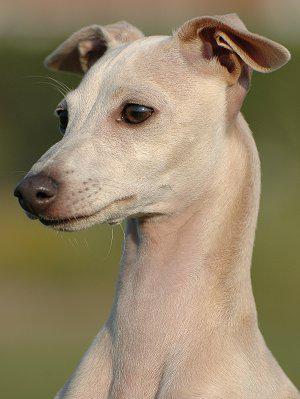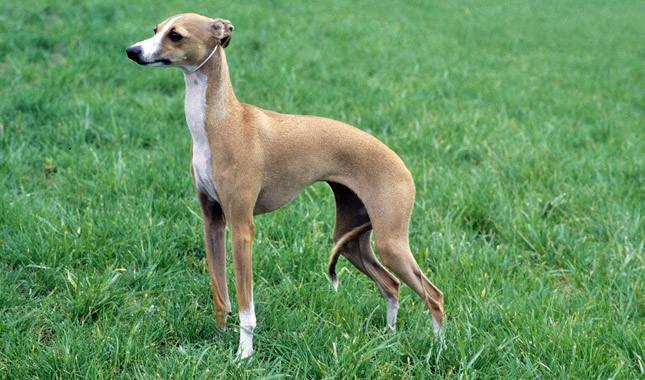The first image is the image on the left, the second image is the image on the right. For the images shown, is this caption "there is a gray dog standing with its body facing right" true? Answer yes or no. No. The first image is the image on the left, the second image is the image on the right. For the images displayed, is the sentence "Both of the dogs are wearing collars." factually correct? Answer yes or no. No. The first image is the image on the left, the second image is the image on the right. Assess this claim about the two images: "The right image shows a dog with all four paws on green grass.". Correct or not? Answer yes or no. Yes. The first image is the image on the left, the second image is the image on the right. Considering the images on both sides, is "The dog in the right image is standing and facing left" valid? Answer yes or no. Yes. 